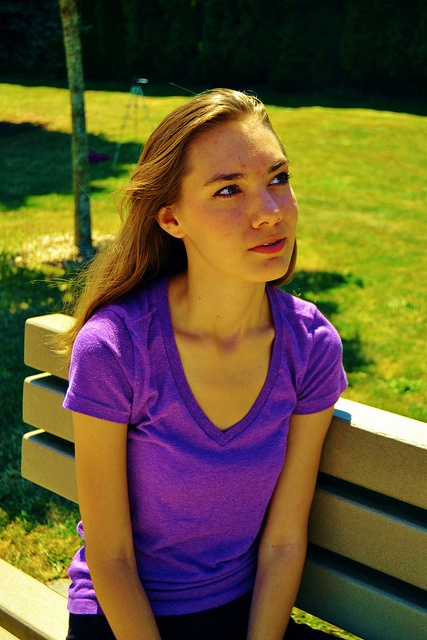Describe the objects in this image and their specific colors. I can see people in black, olive, purple, and navy tones and bench in black, olive, and darkgreen tones in this image. 